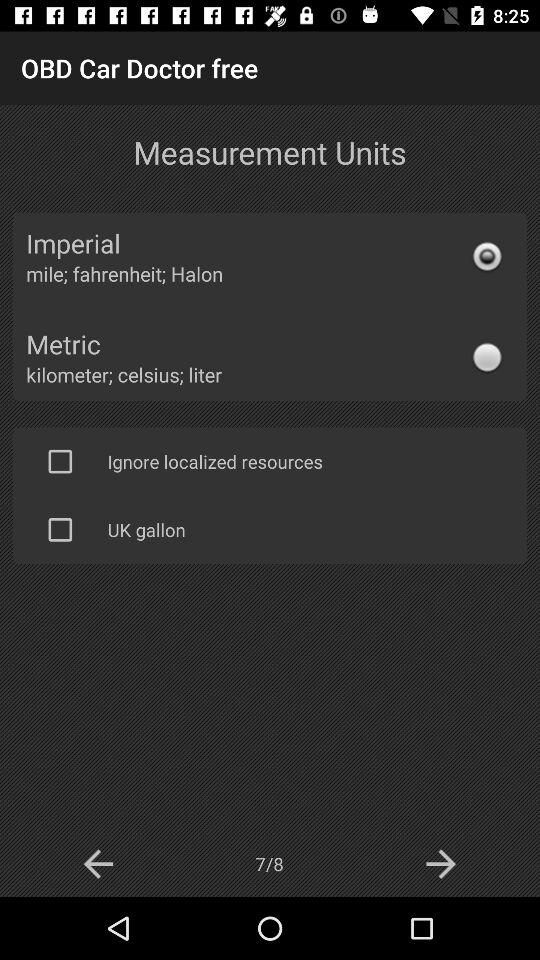Is "UK gallon" selected or not? The "UK gallon" is not selected. 